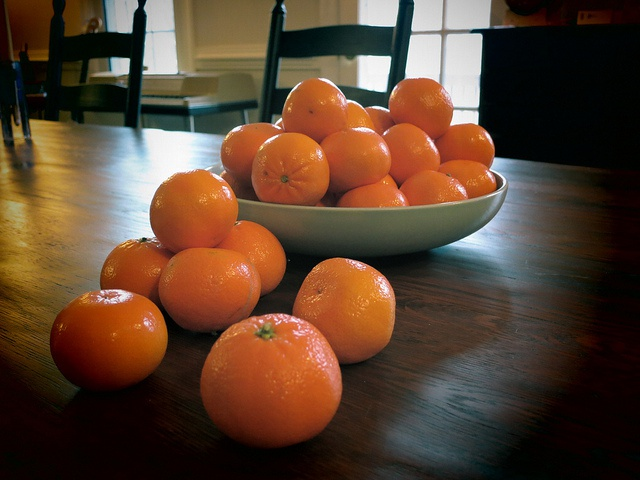Describe the objects in this image and their specific colors. I can see dining table in black, gray, and maroon tones, bowl in black, brown, red, and gray tones, orange in black, brown, red, and maroon tones, orange in black, brown, red, and maroon tones, and orange in black, brown, maroon, and red tones in this image. 